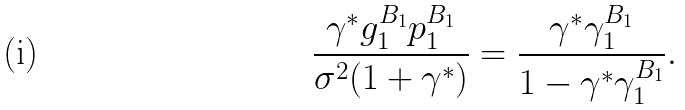<formula> <loc_0><loc_0><loc_500><loc_500>\frac { \gamma ^ { * } g _ { 1 } ^ { B _ { 1 } } p _ { 1 } ^ { B _ { 1 } } } { \sigma ^ { 2 } ( 1 + \gamma ^ { * } ) } = \frac { \gamma ^ { * } \gamma _ { 1 } ^ { B _ { 1 } } } { 1 - \gamma ^ { * } \gamma _ { 1 } ^ { B _ { 1 } } } .</formula> 